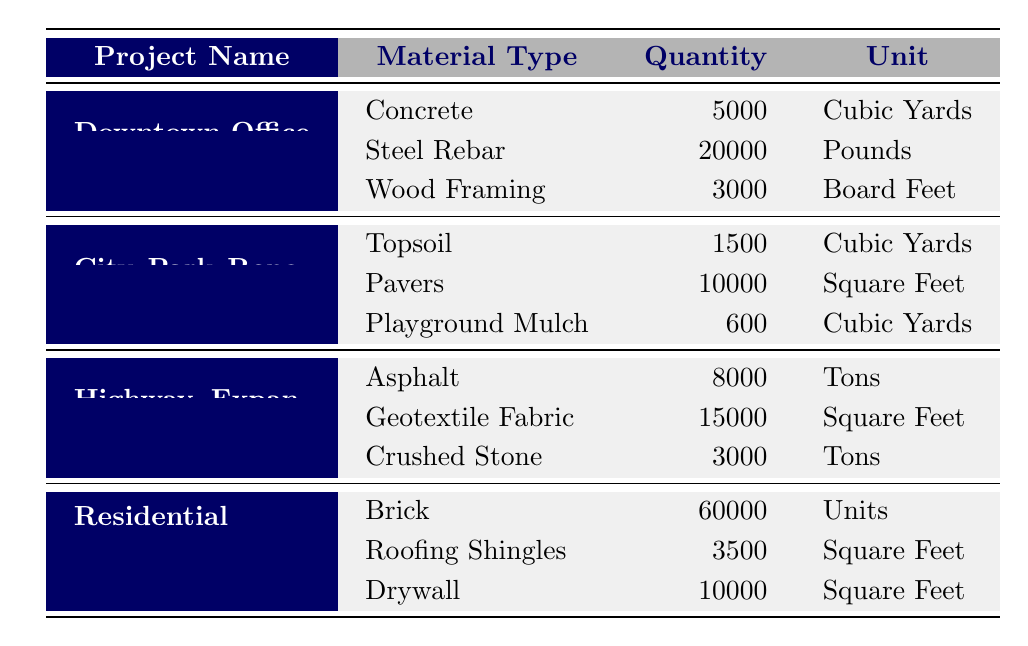What is the total quantity of Concrete used in the Downtown Office Complex? From the table, under the Downtown Office Complex, the material listed is Concrete with a quantity of 5000 Cubic Yards. Since there is only this one entry for Concrete in this project, the total quantity is simply the value shown.
Answer: 5000 Cubic Yards How many Pounds of Steel Rebar were used in the Downtown Office Complex? The table shows that for the Downtown Office Complex, the Steel Rebar material has a quantity listed as 20000 Pounds. Thus, the answer is directly taken from the table.
Answer: 20000 Pounds Is the quantity of Drywall used in the Residential Housing Development greater than the total quantity of Topsoil used in the City Park Renovation? From the table, the quantity of Drywall in the Residential Housing Development is 10000 Square Feet, and the quantity of Topsoil in the City Park Renovation is 1500 Cubic Yards. Since these are different units, we can’t directly compare them without converting the Topsoil quantity. Drywall is in Square Feet while Topsoil in Cubic Yards would need conversion to match the dimensions. Thus, comparing them directly is invalid.
Answer: No What is the total quantity of material used in the Highway Expansion Project? The materials listed for the Highway Expansion Project are Asphalt (8000 Tons), Geotextile Fabric (15000 Square Feet), and Crushed Stone (3000 Tons). To find total material usage, we can sum the quantities but need to acknowledge that the units differ (Tons and Square Feet), making it impossible to give a single value without standardizing units. Therefore, the total of listed materials is as follows: 8000 Tons + 15000 Square Feet + 3000 Tons, but their combination doesn’t yield a meaningful total due to differing units.
Answer: Not calculable Which construction project used the highest number of units for a single material type? The table shows the materials and quantities for each project. The Residential Housing Development has 60000 Units of Brick, which is greater compared to all other materials listed in the other projects. Therefore, this project has the highest quantity for a single material type.
Answer: Residential Housing Development (Brick: 60000 Units) 